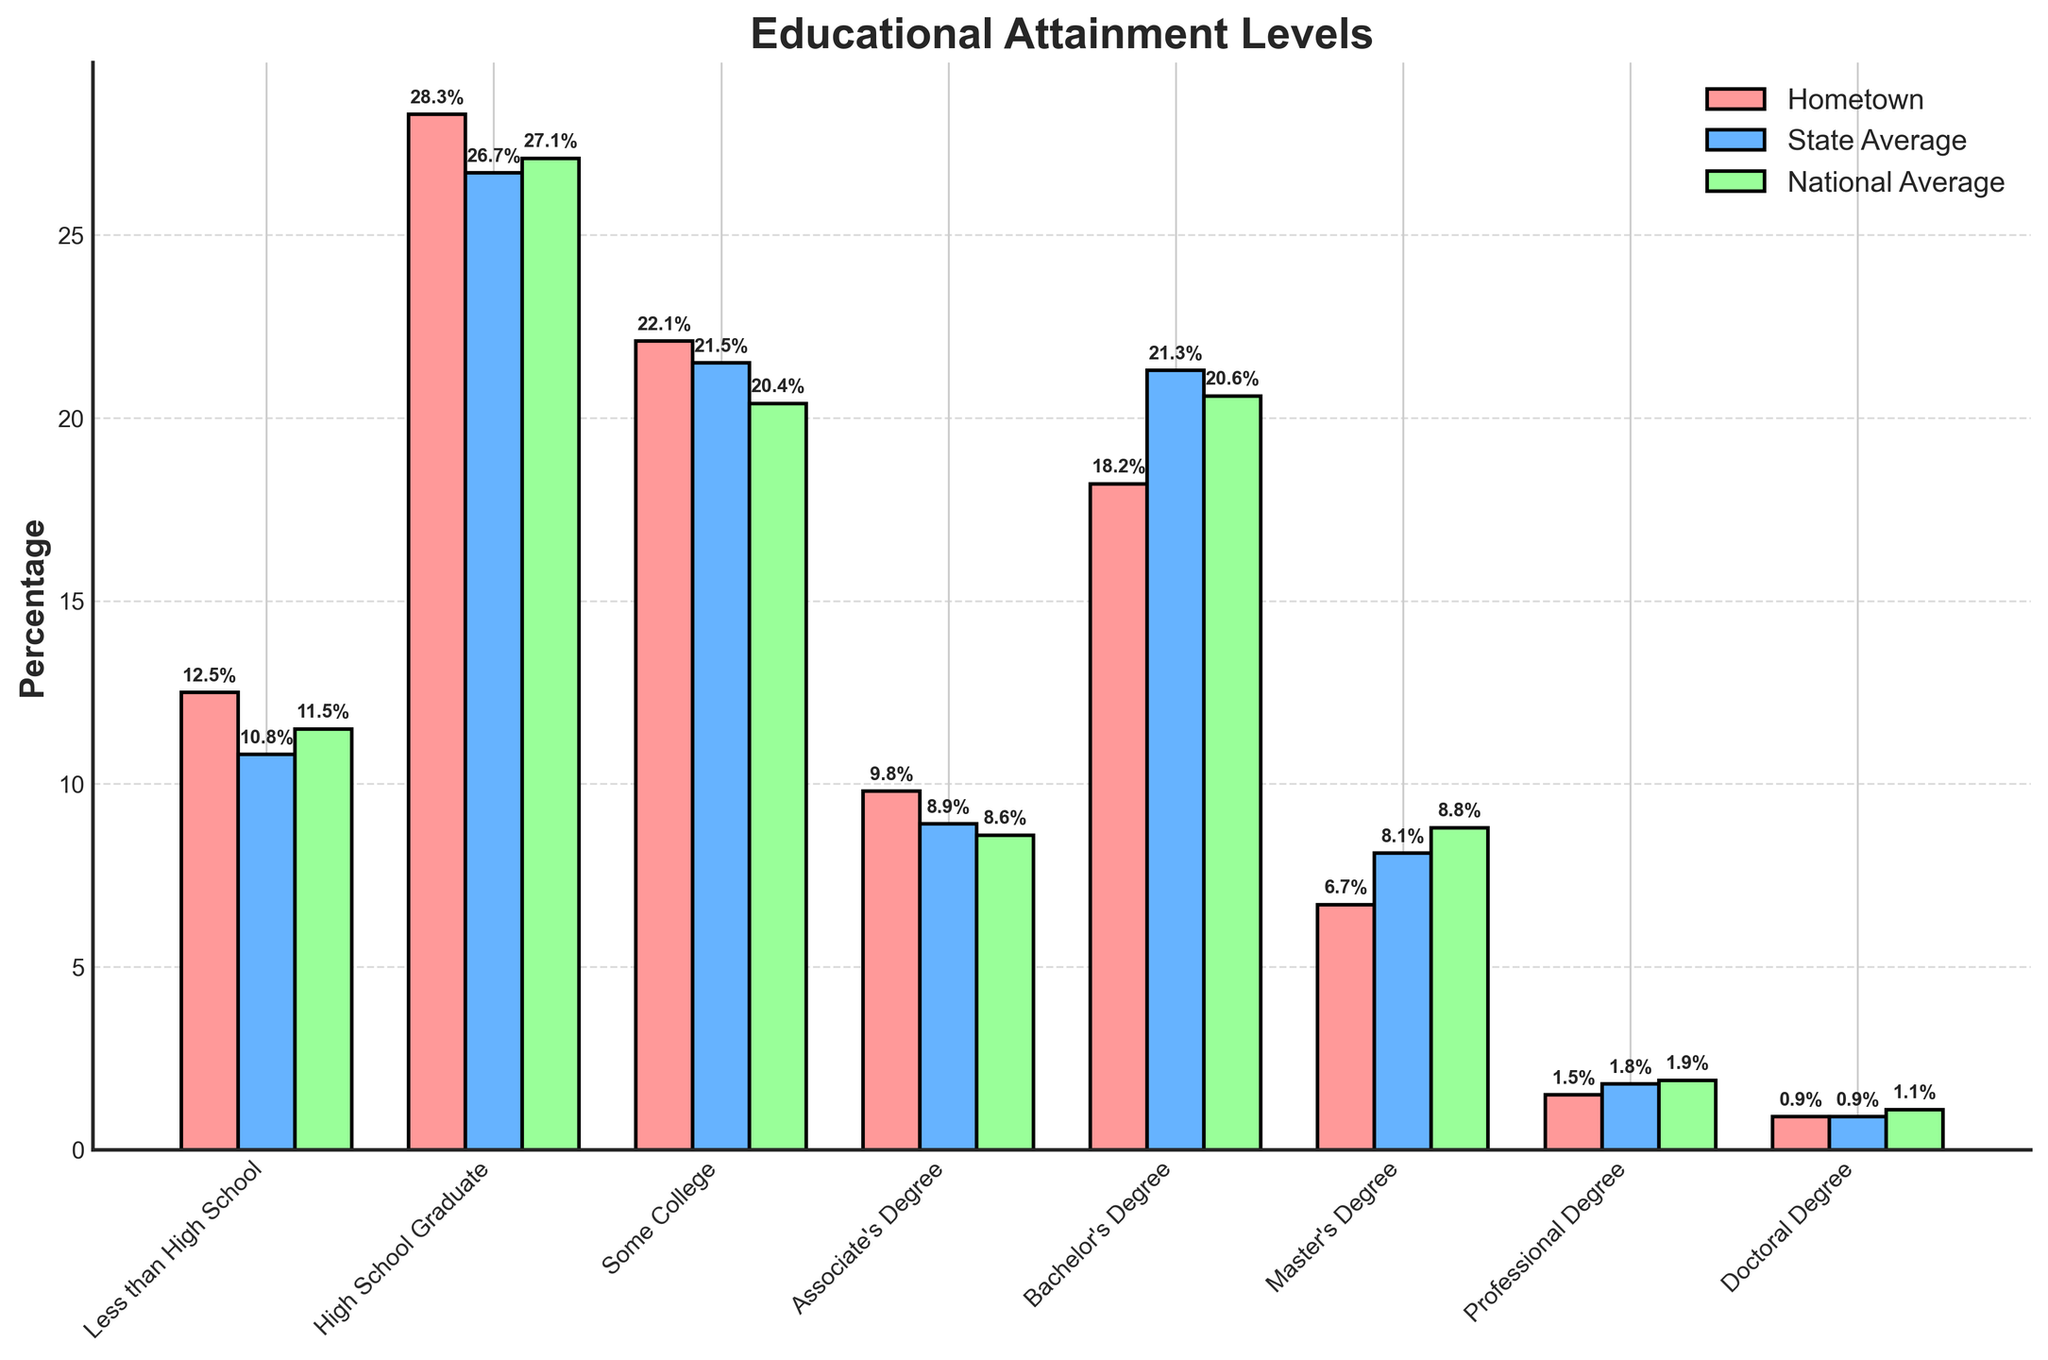What's the percentage of hometown residents with a Bachelor's Degree? Look at the bar corresponding to "Bachelor's Degree" in the "Hometown" series. The label above the bar indicates it is 18.2%.
Answer: 18.2% How does the percentage of High School Graduates in the hometown compare to the state and national averages? Check the bars for "High School Graduate". The hometown bar is 28.3%, the state average bar is 26.7%, and the national average bar is 27.1%. The hometown percentage is higher than both the state and national averages.
Answer: Higher Which educational attainment level has the smallest percentage in the hometown? Identify the shortest bar in the "Hometown" series. The shortest bar corresponds to "Doctoral Degree" with a value of 0.9%.
Answer: Doctoral Degree What is the difference in percentage between hometown residents with a Master's Degree and those with a Bachelor's Degree? Subtract the percentage of Master's Degree holders (6.7%) from the percentage of Bachelor's Degree holders (18.2%). The difference is \(18.2\% - 6.7\% = 11.5\%\).
Answer: 11.5% What is the total percentage of people in the hometown with post-secondary education (Associate's Degree and higher)? Sum the percentages for Associate's Degree (9.8%), Bachelor's Degree (18.2%), Master's Degree (6.7%), Professional Degree (1.5%), and Doctoral Degree (0.9%). The total is \(9.8\% + 18.2\% + 6.7\% + 1.5\% + 0.9\% = 37.1\%\).
Answer: 37.1% Which level of educational attainment shows the greatest disparity between the hometown and national averages? Calculate the absolute differences for all educational levels between the hometown and national averages and identify the largest difference. "Bachelor's Degree" has the greatest absolute difference: \(20.6\% - 18.2\% = 2.4\%\).
Answer: Bachelor's Degree What is the combined percentage of hometown residents with a High School Graduate level or higher? Sum the percentages for High School Graduate (28.3%), Some College (22.1%), Associate's Degree (9.8%), Bachelor's Degree (18.2%), Master's Degree (6.7%), Professional Degree (1.5%), and Doctoral Degree (0.9%). The total is \(28.3\% + 22.1\% + 9.8\% + 18.2\% + 6.7\% + 1.5\% + 0.9\% = 87.5\%\).
Answer: 87.5% Is the percentage of residents with "Less than High School" higher, lower, or the same in the hometown compared to the state average? Compare the bars for "Less than High School". The hometown bar is 12.5%, and the state average bar is 10.8%. The hometown percentage is higher.
Answer: Higher 